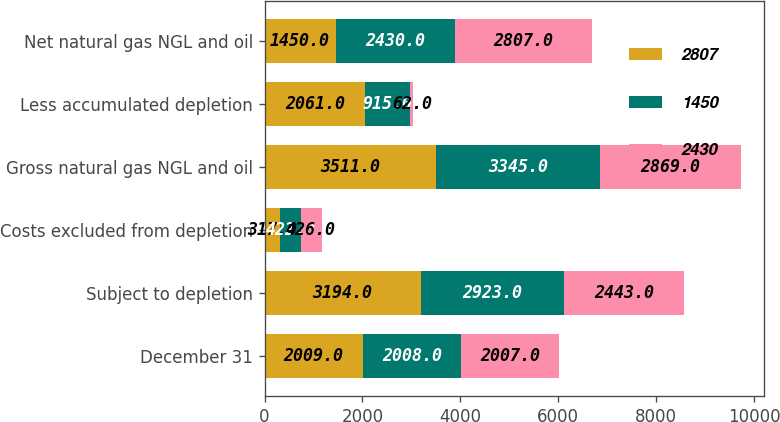Convert chart to OTSL. <chart><loc_0><loc_0><loc_500><loc_500><stacked_bar_chart><ecel><fcel>December 31<fcel>Subject to depletion<fcel>Costs excluded from depletion<fcel>Gross natural gas NGL and oil<fcel>Less accumulated depletion<fcel>Net natural gas NGL and oil<nl><fcel>2807<fcel>2009<fcel>3194<fcel>317<fcel>3511<fcel>2061<fcel>1450<nl><fcel>1450<fcel>2008<fcel>2923<fcel>422<fcel>3345<fcel>915<fcel>2430<nl><fcel>2430<fcel>2007<fcel>2443<fcel>426<fcel>2869<fcel>62<fcel>2807<nl></chart> 